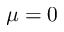<formula> <loc_0><loc_0><loc_500><loc_500>\mu = 0</formula> 